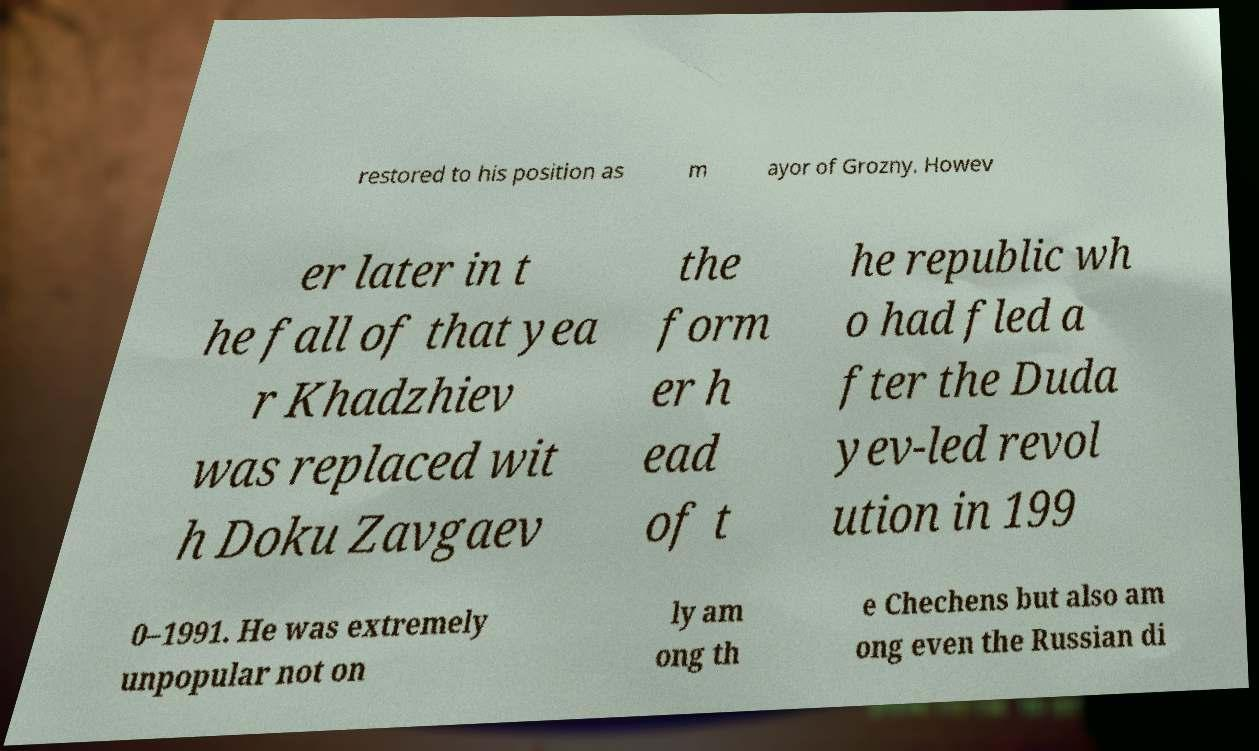There's text embedded in this image that I need extracted. Can you transcribe it verbatim? restored to his position as m ayor of Grozny. Howev er later in t he fall of that yea r Khadzhiev was replaced wit h Doku Zavgaev the form er h ead of t he republic wh o had fled a fter the Duda yev-led revol ution in 199 0–1991. He was extremely unpopular not on ly am ong th e Chechens but also am ong even the Russian di 